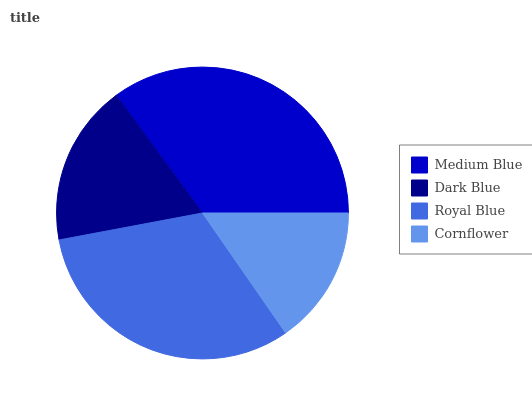Is Cornflower the minimum?
Answer yes or no. Yes. Is Medium Blue the maximum?
Answer yes or no. Yes. Is Dark Blue the minimum?
Answer yes or no. No. Is Dark Blue the maximum?
Answer yes or no. No. Is Medium Blue greater than Dark Blue?
Answer yes or no. Yes. Is Dark Blue less than Medium Blue?
Answer yes or no. Yes. Is Dark Blue greater than Medium Blue?
Answer yes or no. No. Is Medium Blue less than Dark Blue?
Answer yes or no. No. Is Royal Blue the high median?
Answer yes or no. Yes. Is Dark Blue the low median?
Answer yes or no. Yes. Is Medium Blue the high median?
Answer yes or no. No. Is Cornflower the low median?
Answer yes or no. No. 